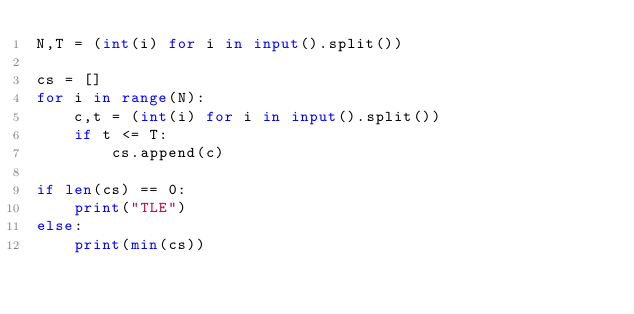Convert code to text. <code><loc_0><loc_0><loc_500><loc_500><_Python_>N,T = (int(i) for i in input().split())

cs = []
for i in range(N):
    c,t = (int(i) for i in input().split())
    if t <= T:
        cs.append(c)

if len(cs) == 0:
    print("TLE")
else:
    print(min(cs))</code> 